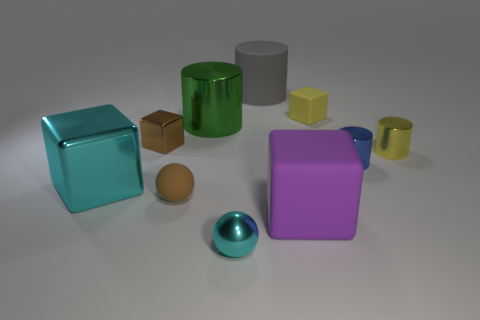Subtract all large gray cylinders. How many cylinders are left? 3 Subtract 1 cylinders. How many cylinders are left? 3 Subtract all cyan blocks. How many blocks are left? 3 Add 2 cylinders. How many cylinders are left? 6 Add 9 big gray rubber objects. How many big gray rubber objects exist? 10 Subtract 1 yellow cylinders. How many objects are left? 9 Subtract all spheres. How many objects are left? 8 Subtract all blue balls. Subtract all red blocks. How many balls are left? 2 Subtract all purple blocks. How many blue balls are left? 0 Subtract all small matte things. Subtract all blue shiny cylinders. How many objects are left? 7 